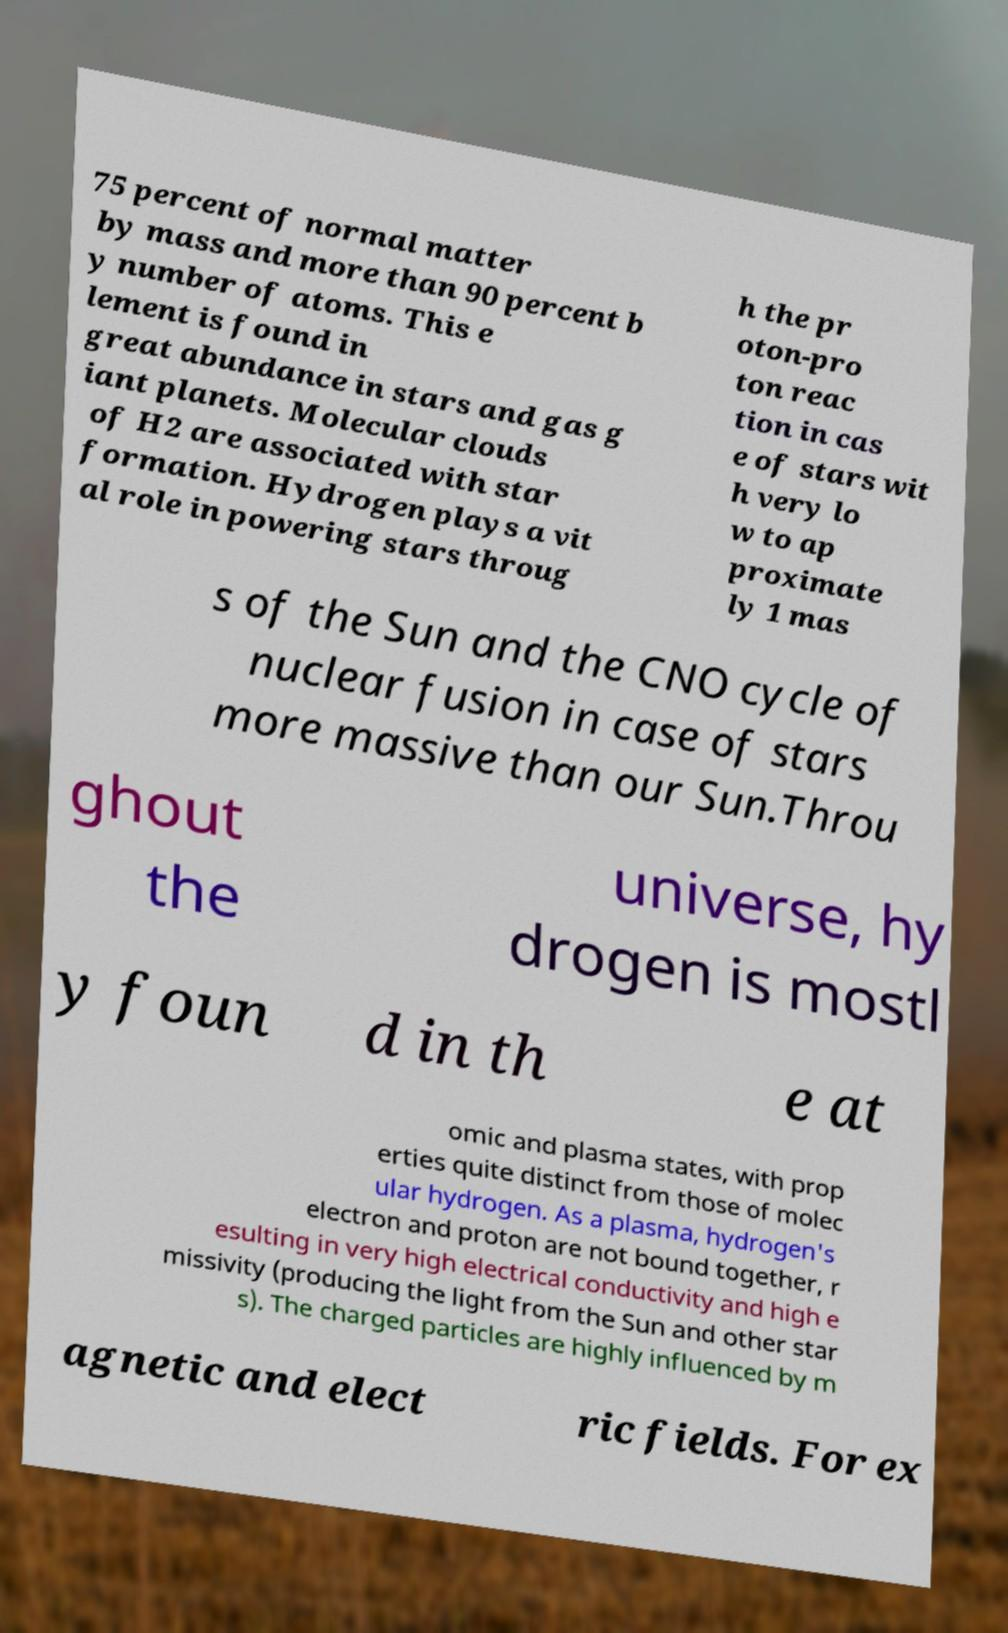Please read and relay the text visible in this image. What does it say? 75 percent of normal matter by mass and more than 90 percent b y number of atoms. This e lement is found in great abundance in stars and gas g iant planets. Molecular clouds of H2 are associated with star formation. Hydrogen plays a vit al role in powering stars throug h the pr oton-pro ton reac tion in cas e of stars wit h very lo w to ap proximate ly 1 mas s of the Sun and the CNO cycle of nuclear fusion in case of stars more massive than our Sun.Throu ghout the universe, hy drogen is mostl y foun d in th e at omic and plasma states, with prop erties quite distinct from those of molec ular hydrogen. As a plasma, hydrogen's electron and proton are not bound together, r esulting in very high electrical conductivity and high e missivity (producing the light from the Sun and other star s). The charged particles are highly influenced by m agnetic and elect ric fields. For ex 